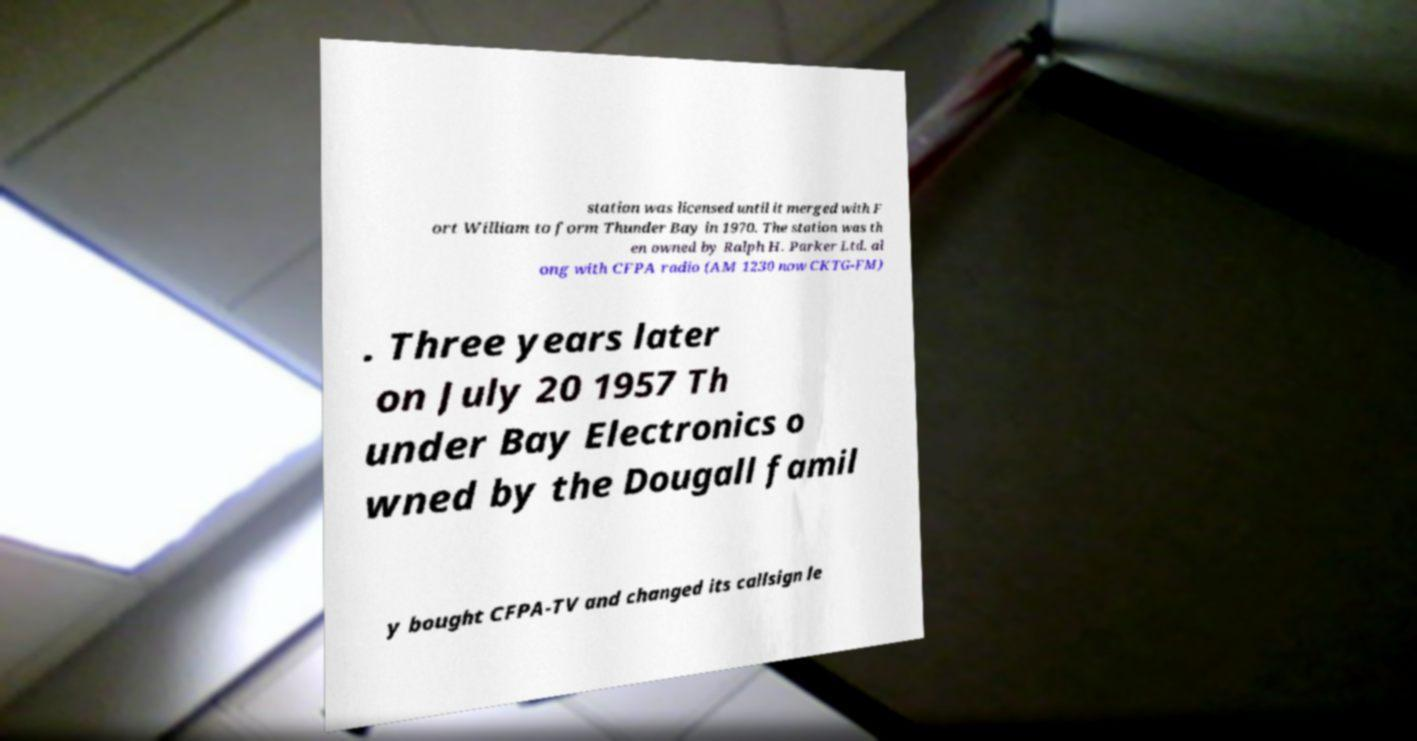Could you extract and type out the text from this image? station was licensed until it merged with F ort William to form Thunder Bay in 1970. The station was th en owned by Ralph H. Parker Ltd. al ong with CFPA radio (AM 1230 now CKTG-FM) . Three years later on July 20 1957 Th under Bay Electronics o wned by the Dougall famil y bought CFPA-TV and changed its callsign le 